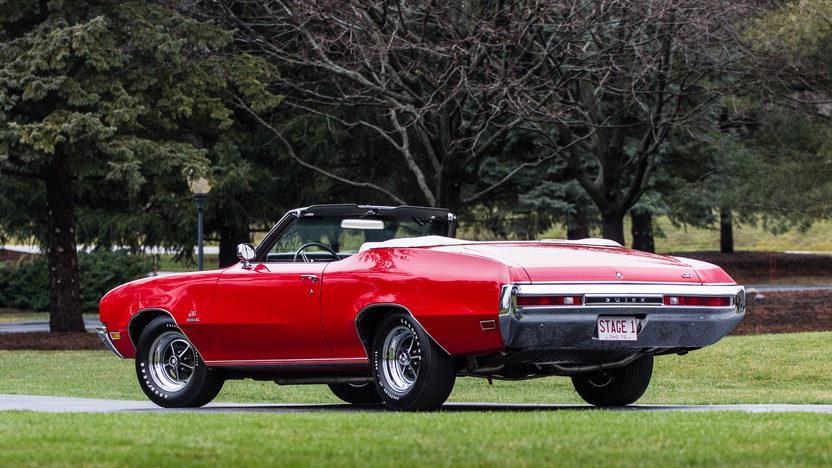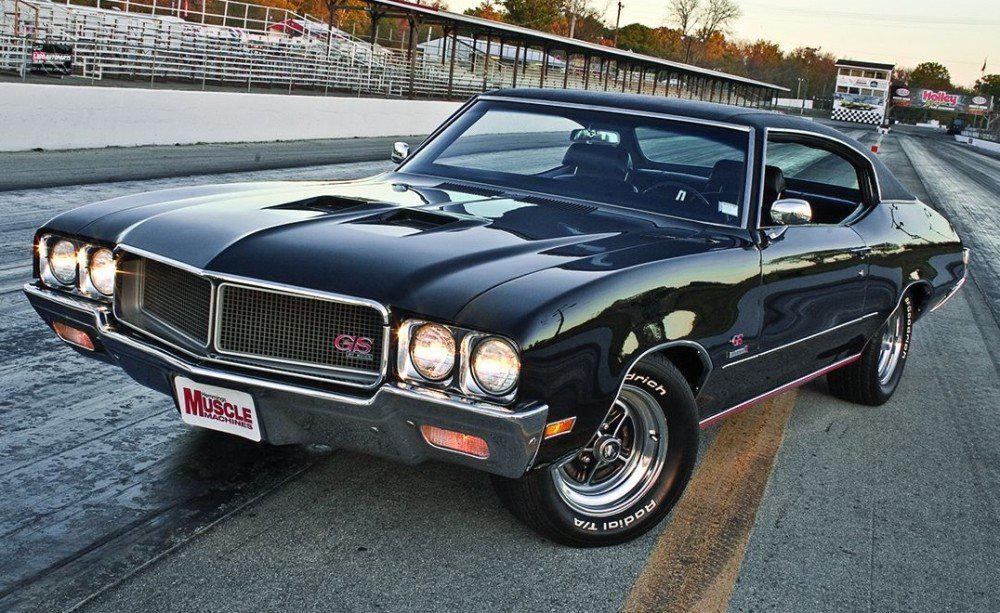The first image is the image on the left, the second image is the image on the right. For the images shown, is this caption "The image on the right contains a red convertible." true? Answer yes or no. No. 